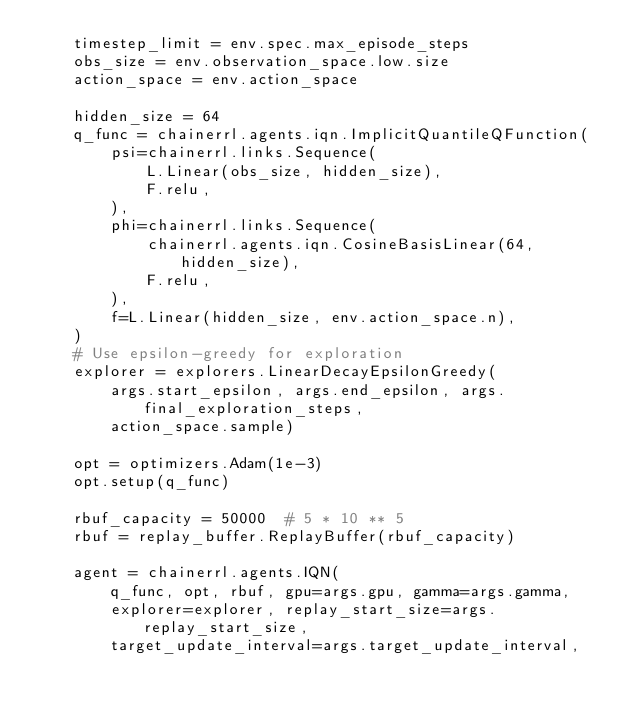Convert code to text. <code><loc_0><loc_0><loc_500><loc_500><_Python_>    timestep_limit = env.spec.max_episode_steps
    obs_size = env.observation_space.low.size
    action_space = env.action_space

    hidden_size = 64
    q_func = chainerrl.agents.iqn.ImplicitQuantileQFunction(
        psi=chainerrl.links.Sequence(
            L.Linear(obs_size, hidden_size),
            F.relu,
        ),
        phi=chainerrl.links.Sequence(
            chainerrl.agents.iqn.CosineBasisLinear(64, hidden_size),
            F.relu,
        ),
        f=L.Linear(hidden_size, env.action_space.n),
    )
    # Use epsilon-greedy for exploration
    explorer = explorers.LinearDecayEpsilonGreedy(
        args.start_epsilon, args.end_epsilon, args.final_exploration_steps,
        action_space.sample)

    opt = optimizers.Adam(1e-3)
    opt.setup(q_func)

    rbuf_capacity = 50000  # 5 * 10 ** 5
    rbuf = replay_buffer.ReplayBuffer(rbuf_capacity)

    agent = chainerrl.agents.IQN(
        q_func, opt, rbuf, gpu=args.gpu, gamma=args.gamma,
        explorer=explorer, replay_start_size=args.replay_start_size,
        target_update_interval=args.target_update_interval,</code> 